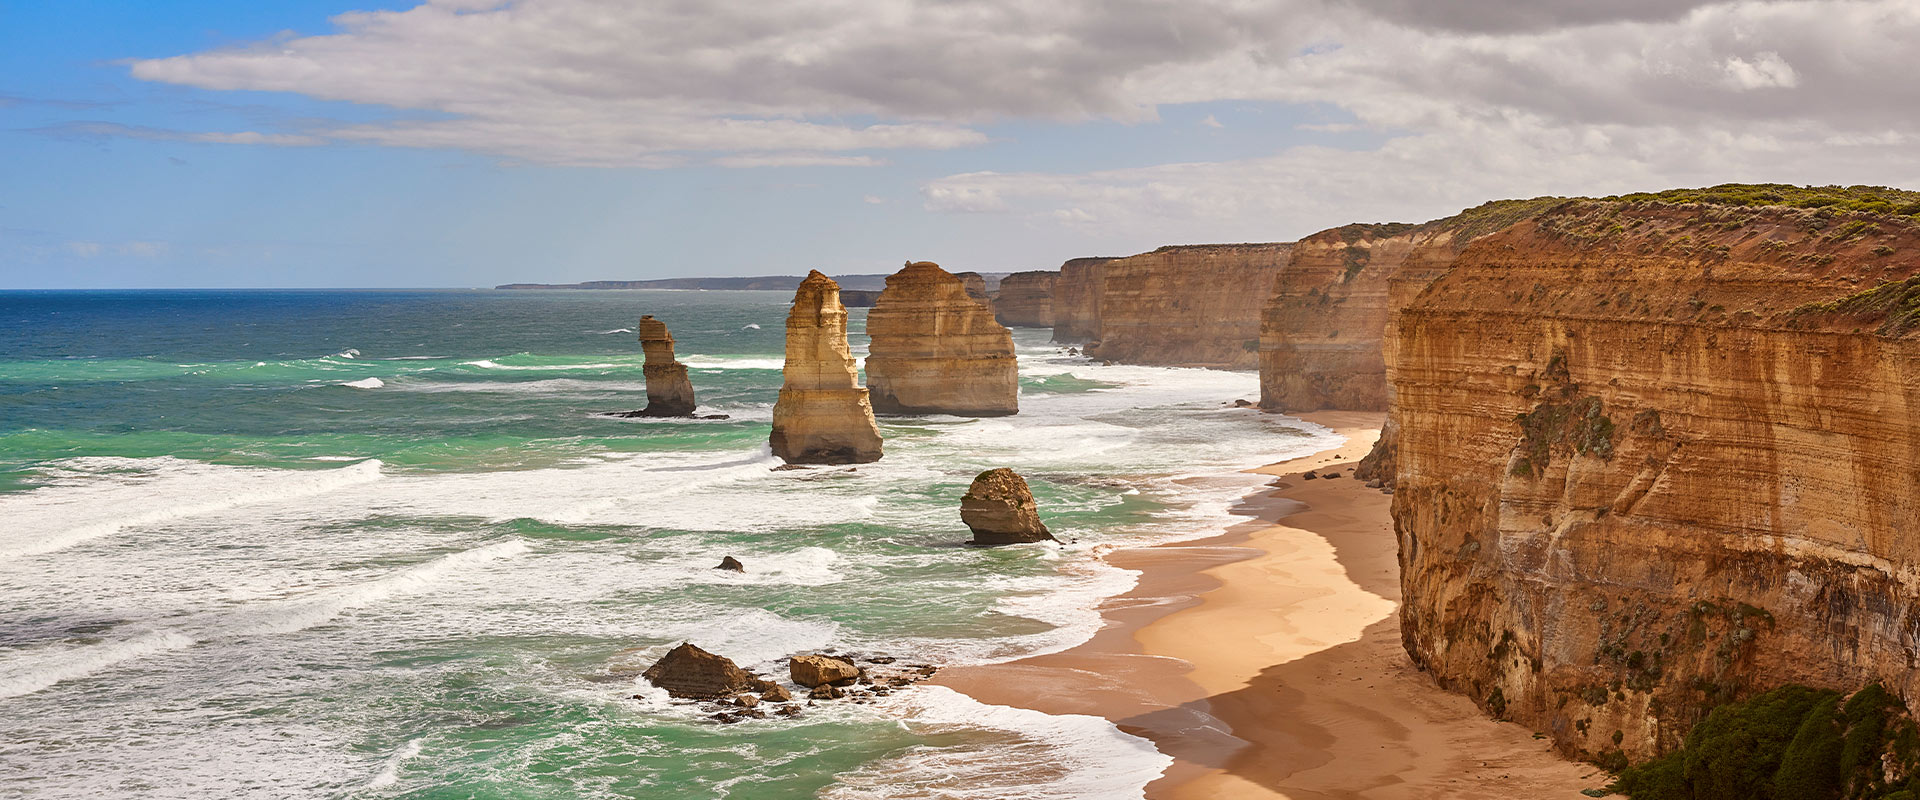Can you elaborate on the elements of the picture provided? This image showcases the stunning Twelve Apostles, located along the coast of the Port Campbell National Park in Victoria, Australia. These limestone stacks, eroded from the mainland cliffs by the relentless Southern Ocean, stand as a natural testament to the power of nature. With heights varying dramatically, they are colored in a dynamic range of orange and tan hues, contrasting beautifully against the dark, crashing waves and the sandy shores. From this elevated perspective, the photograph captures the dramatic skies forming an almost theatrical backdrop to the scenic oceanfront, making this a truly captivating view. The site's natural beauty and its role in Australian natural heritage are significant, making it a popular destination for both tourism and scientific study. 